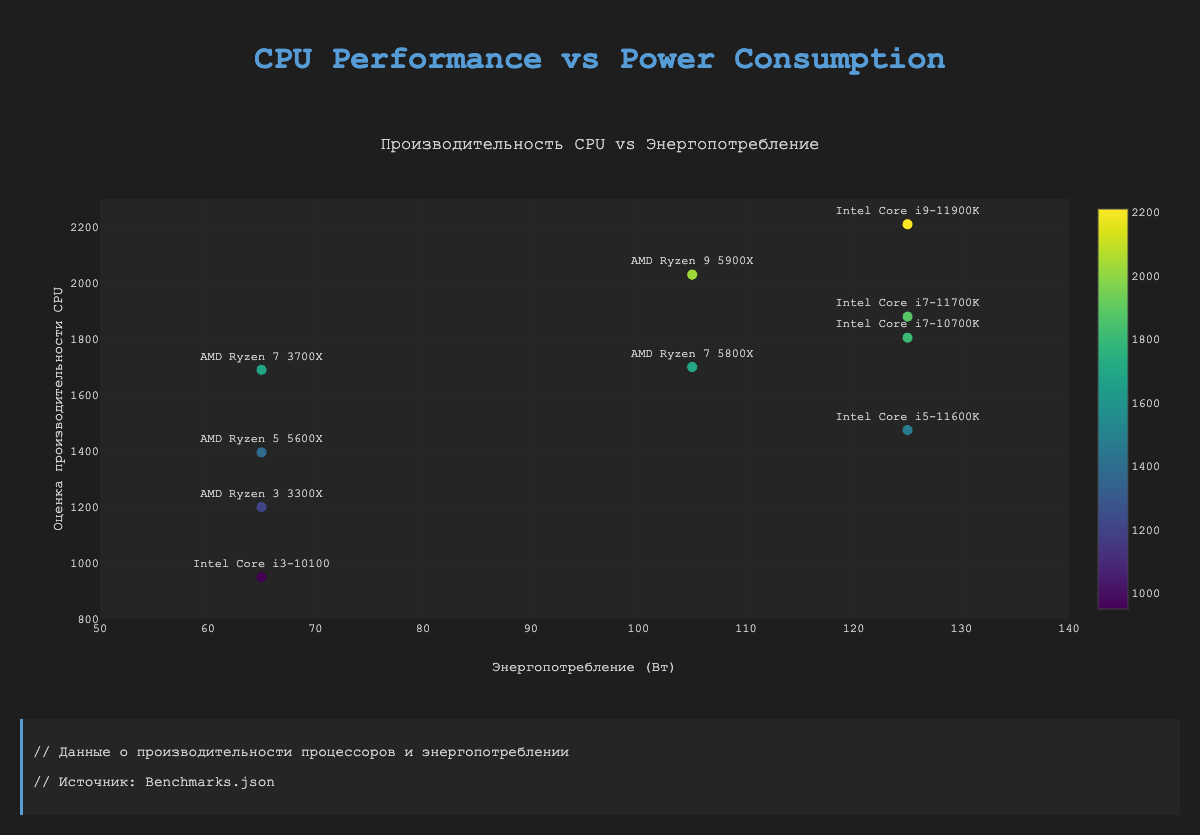How many data points represent processors with a power consumption of 125 watts? To find the data points with a power consumption of 125 watts, look at the x-axis (power consumption) values and count the number of points that correspond to 125 watts. There are four data points with power consumption of 125 watts (Intel Core i9-11900K, Intel Core i7-11700K, Intel Core i5-11600K, Intel Core i7-10700K).
Answer: 4 How does the performance of Intel Core i9-11900K compare to AMD Ryzen 9 5900X? Locate the Intel Core i9-11900K and AMD Ryzen 9 5900X on the graph by looking at their respective benchmark scores and power consumption values. The Intel Core i9-11900K has a higher score (2210) compared to AMD Ryzen 9 5900X (2030).
Answer: Intel Core i9-11900K has a higher benchmark score than AMD Ryzen 9 5900X What is the average power consumption of AMD processors in the dataset? First, identify all AMD processors and their power consumption values (105, 105, 65, 65, 65). Then, calculate the average by summing these values and dividing by the number of AMD processors. The sum is 405 and there are 5 processors, so the average is 405/5 = 81.
Answer: 81 watts Which processor has the lowest benchmark score, and what is that score? Locate the data point representing the lowest value on the y-axis (CPU benchmark score) and identify the corresponding processor model. The Intel Core i3-10100 has the lowest benchmark score of 950.
Answer: Intel Core i3-10100, 950 Is there a positive correlation between CPU performance and power consumption? Examine the scatter plot to see if higher power consumption generally corresponds to higher CPU benchmark scores. The trend line indicates an overall upward trend, which suggests a positive correlation.
Answer: Yes, there is a positive correlation What is the total power consumption of all processors combined? Sum the power consumption values of all processors (125, 105, 125, 105, 125, 65, 65, 65, 125, 65). The total is 960 watts.
Answer: 960 watts Which model has the highest power consumption and how much is it? Identify the data point with the highest x-axis value (power consumption). The models with the highest power consumption of 125 watts are Intel Core i9-11900K, Intel Core i7-11700K, Intel Core i5-11600K, Intel Core i7-10700K.
Answer: Intel Core i9-11900K, Intel Core i7-11700K, Intel Core i5-11600K, Intel Core i7-10700K, 125 watts Between AMD Ryzen 7 5800X and AMD Ryzen 7 3700X, which has a higher CPU benchmark score? Look at the y-axis values for AMD Ryzen 7 5800X (1700) and AMD Ryzen 7 3700X (1690) to compare their benchmark scores. The AMD Ryzen 7 5800X has a higher score.
Answer: AMD Ryzen 7 5800X What is the range of CPU benchmark scores for processors with 65 watts power consumption? Identify all processors with 65 watts of power consumption and determine their respective CPU benchmark scores (1395, 950, 1200, 1690). The range is the difference between the highest and lowest scores: 1690 - 950 = 740.
Answer: 740 How many processors have a CPU benchmark score greater than 2000? Count the data points with y-axis values (CPU benchmark score) greater than 2000. Only Intel Core i9-11900K (2210) and AMD Ryzen 9 5900X (2030) have scores greater than 2000.
Answer: 2 